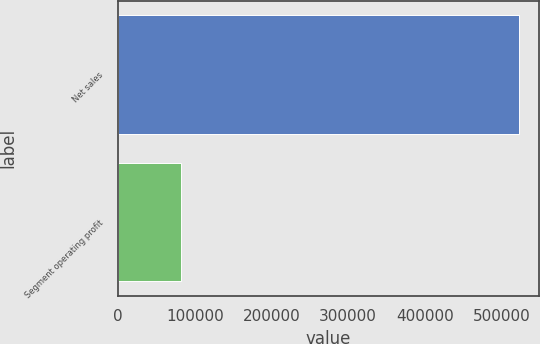Convert chart to OTSL. <chart><loc_0><loc_0><loc_500><loc_500><bar_chart><fcel>Net sales<fcel>Segment operating profit<nl><fcel>522751<fcel>81494<nl></chart> 